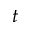Convert formula to latex. <formula><loc_0><loc_0><loc_500><loc_500>t</formula> 